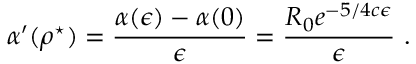<formula> <loc_0><loc_0><loc_500><loc_500>\alpha ^ { \prime } ( \rho ^ { ^ { * } } ) = \frac { \alpha ( \epsilon ) - \alpha ( 0 ) } { \epsilon } = \frac { R _ { 0 } e ^ { - 5 / 4 c \epsilon } } { \epsilon } \ .</formula> 